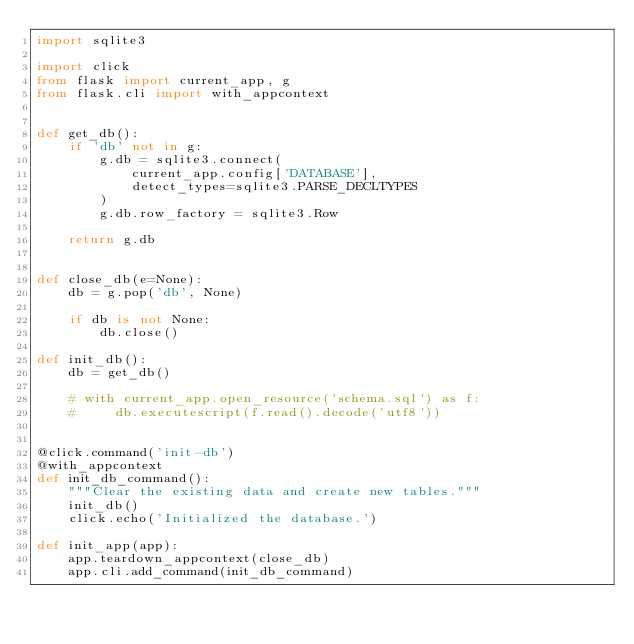Convert code to text. <code><loc_0><loc_0><loc_500><loc_500><_Python_>import sqlite3

import click
from flask import current_app, g
from flask.cli import with_appcontext


def get_db():
    if 'db' not in g:
        g.db = sqlite3.connect(
            current_app.config['DATABASE'],
            detect_types=sqlite3.PARSE_DECLTYPES
        )
        g.db.row_factory = sqlite3.Row

    return g.db


def close_db(e=None):
    db = g.pop('db', None)

    if db is not None:
        db.close()

def init_db():
    db = get_db()

    # with current_app.open_resource('schema.sql') as f:
    #     db.executescript(f.read().decode('utf8'))


@click.command('init-db')
@with_appcontext
def init_db_command():
    """Clear the existing data and create new tables."""
    init_db()
    click.echo('Initialized the database.')

def init_app(app):
    app.teardown_appcontext(close_db)
    app.cli.add_command(init_db_command)</code> 